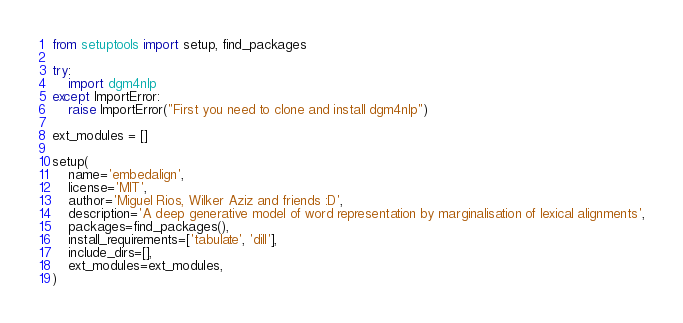Convert code to text. <code><loc_0><loc_0><loc_500><loc_500><_Python_>from setuptools import setup, find_packages

try:
    import dgm4nlp
except ImportError:
    raise ImportError("First you need to clone and install dgm4nlp")

ext_modules = []

setup(
    name='embedalign',
    license='MIT',
    author='Miguel Rios, Wilker Aziz and friends :D',
    description='A deep generative model of word representation by marginalisation of lexical alignments',
    packages=find_packages(),
    install_requirements=['tabulate', 'dill'],
    include_dirs=[],
    ext_modules=ext_modules,
)
</code> 